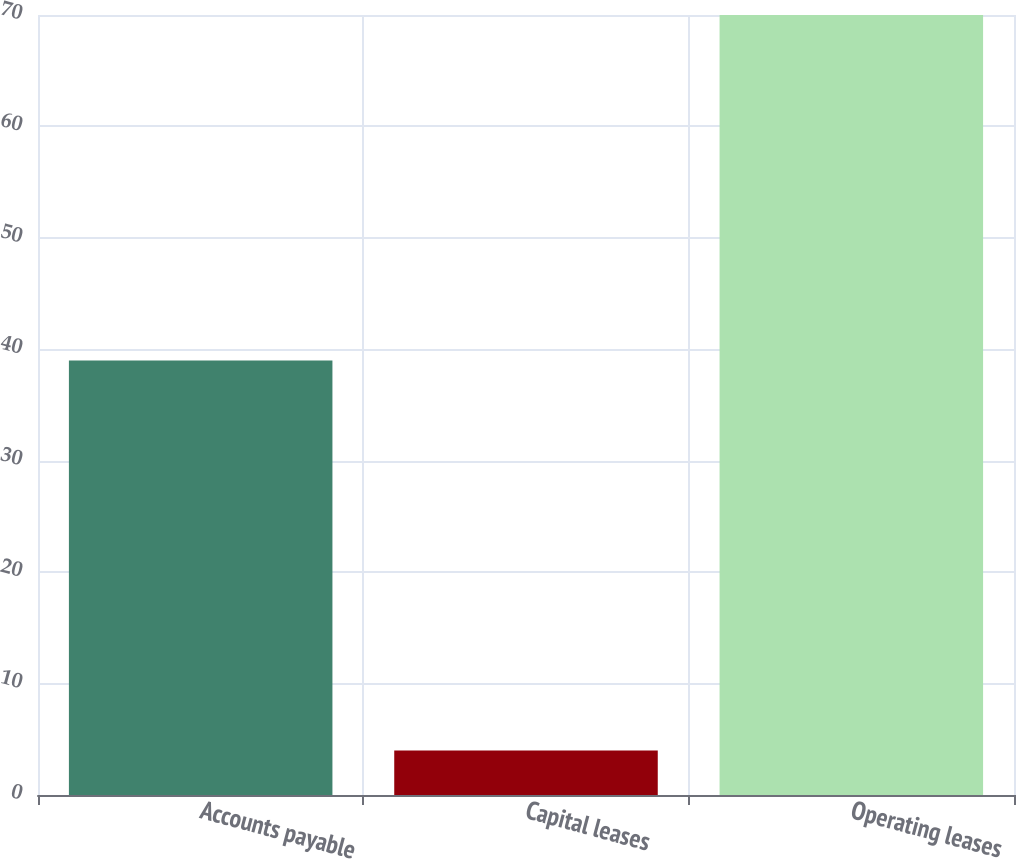<chart> <loc_0><loc_0><loc_500><loc_500><bar_chart><fcel>Accounts payable<fcel>Capital leases<fcel>Operating leases<nl><fcel>39<fcel>4<fcel>70<nl></chart> 